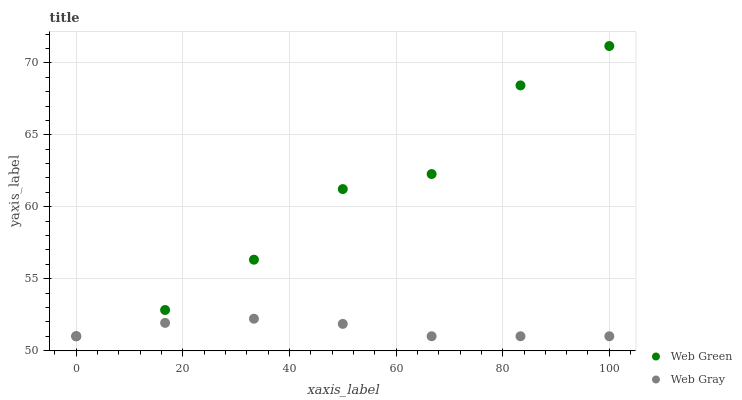Does Web Gray have the minimum area under the curve?
Answer yes or no. Yes. Does Web Green have the maximum area under the curve?
Answer yes or no. Yes. Does Web Green have the minimum area under the curve?
Answer yes or no. No. Is Web Gray the smoothest?
Answer yes or no. Yes. Is Web Green the roughest?
Answer yes or no. Yes. Is Web Green the smoothest?
Answer yes or no. No. Does Web Gray have the lowest value?
Answer yes or no. Yes. Does Web Green have the highest value?
Answer yes or no. Yes. Does Web Gray intersect Web Green?
Answer yes or no. Yes. Is Web Gray less than Web Green?
Answer yes or no. No. Is Web Gray greater than Web Green?
Answer yes or no. No. 